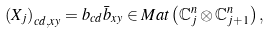Convert formula to latex. <formula><loc_0><loc_0><loc_500><loc_500>\left ( X _ { j } \right ) _ { c d , x y } = b _ { c d } \bar { b } _ { x y } \in M a t \left ( \mathbb { C } _ { j } ^ { n } \otimes \mathbb { C } _ { j + 1 } ^ { n } \right ) ,</formula> 